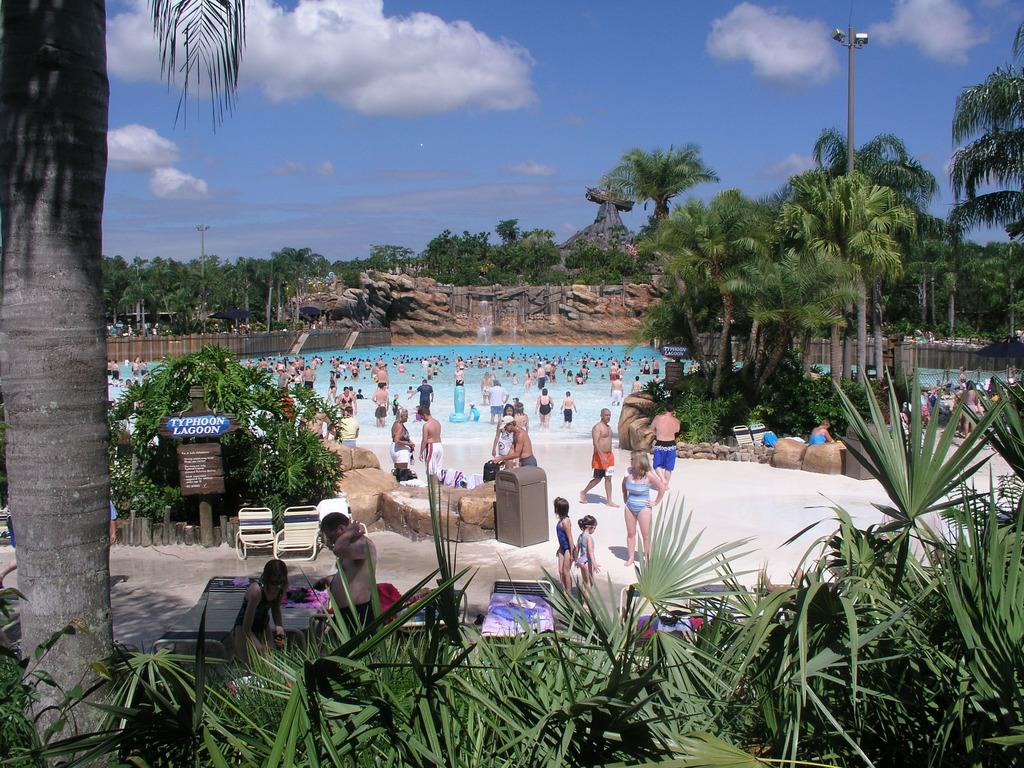What type of vegetation is at the bottom of the image? There are trees at the bottom of the image. What can be seen in the middle of the image? There appears to be a swimming pool in the middle of the image. How many people are in the swimming pool? There are many people in the swimming pool. What is visible at the top of the image? The sky is visible at the top of the image. Where is the hole in the image? There is no hole present in the image. How does the rhythm of the baby affect the swimming pool? There is no baby present in the image, so it is not possible to determine the effect of its rhythm on the swimming pool. 